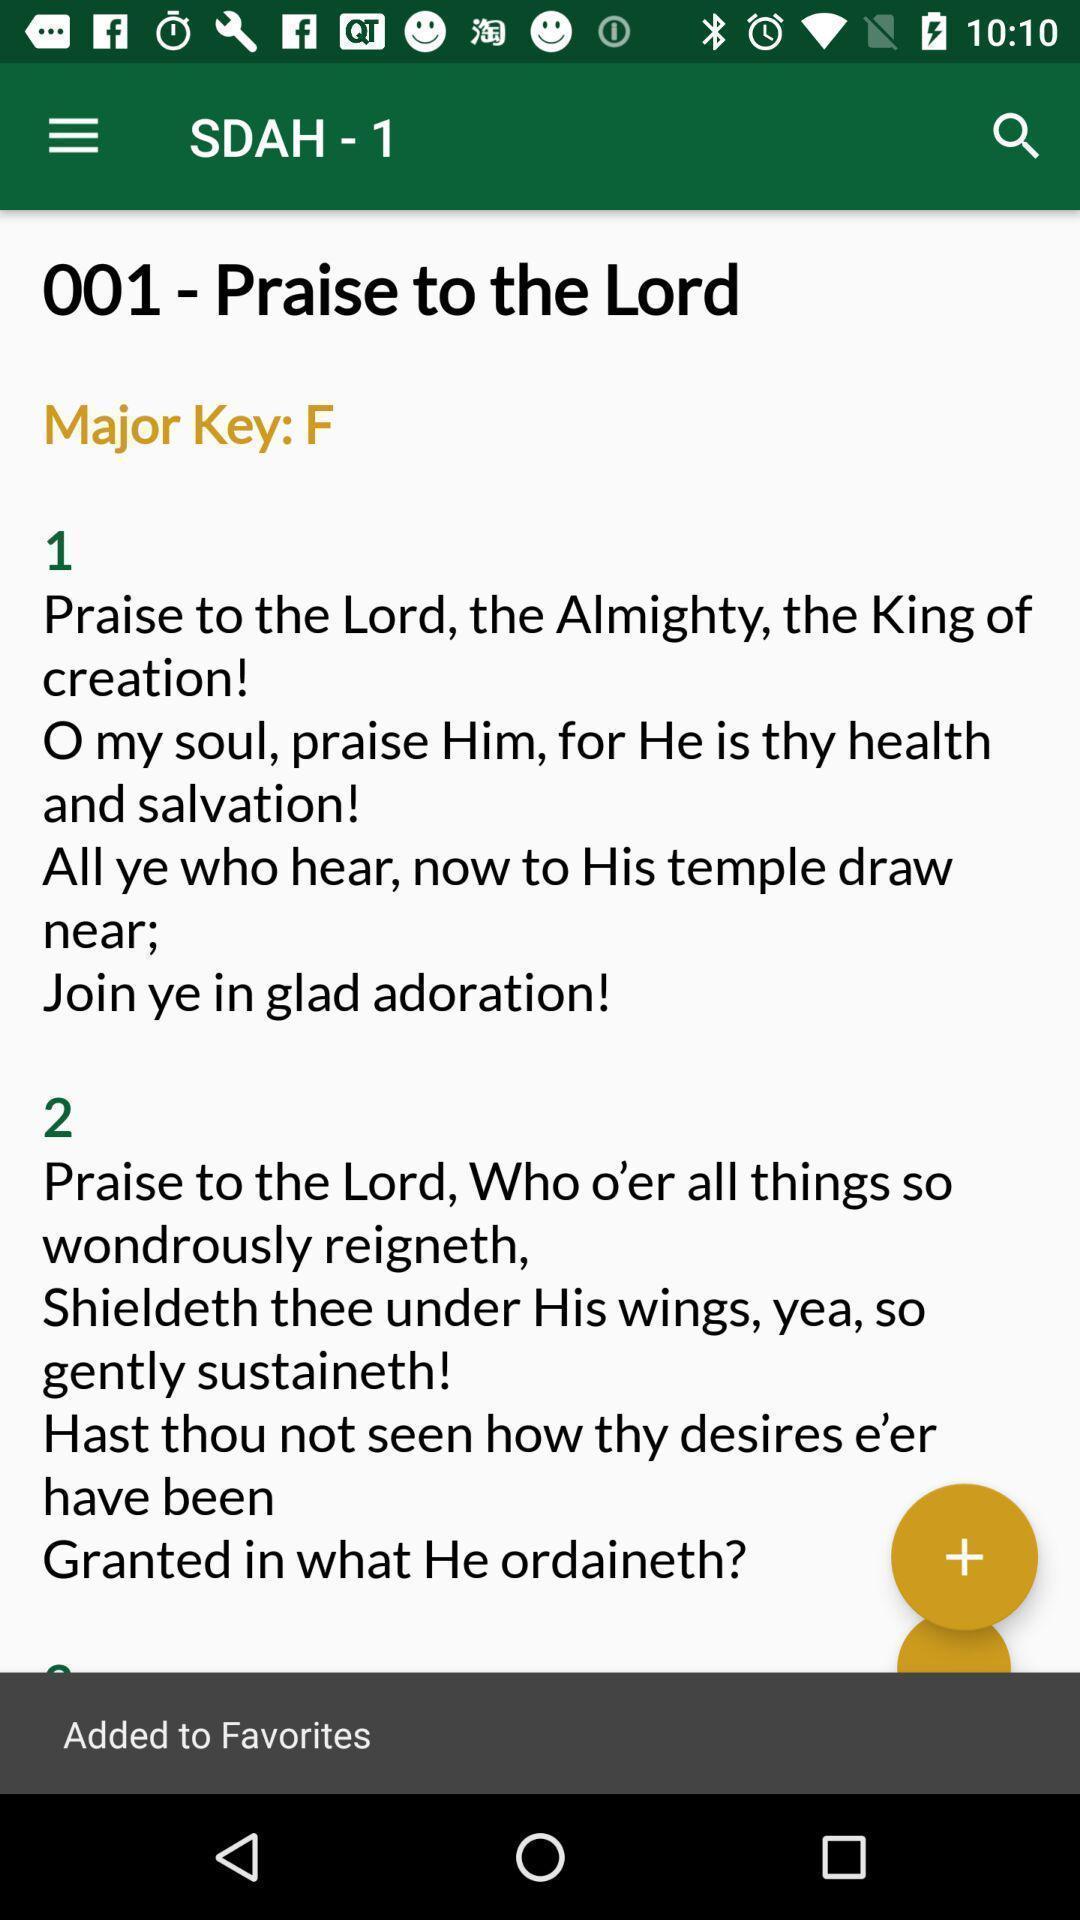Provide a description of this screenshot. Praise hymns in a hymns app. 